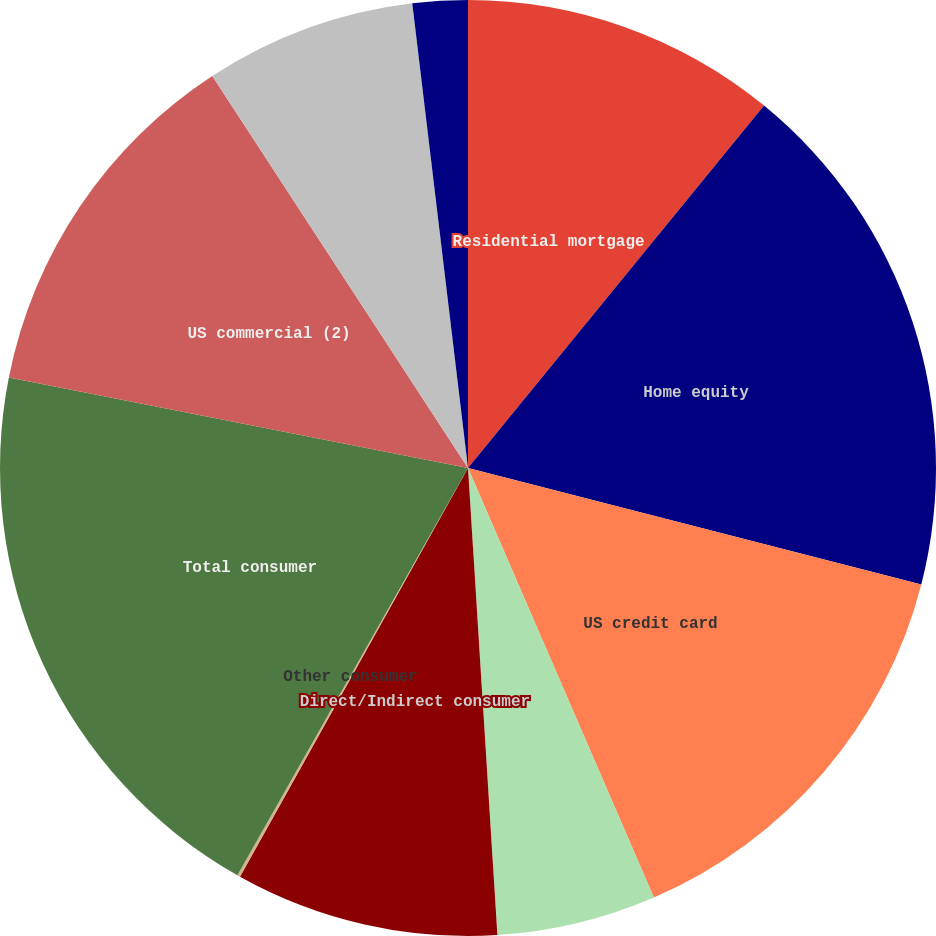Convert chart. <chart><loc_0><loc_0><loc_500><loc_500><pie_chart><fcel>Residential mortgage<fcel>Home equity<fcel>US credit card<fcel>Non-US credit card<fcel>Direct/Indirect consumer<fcel>Other consumer<fcel>Total consumer<fcel>US commercial (2)<fcel>Commercial real estate<fcel>Commercial lease financing<nl><fcel>10.9%<fcel>18.1%<fcel>14.5%<fcel>5.5%<fcel>9.1%<fcel>0.1%<fcel>19.9%<fcel>12.7%<fcel>7.3%<fcel>1.9%<nl></chart> 